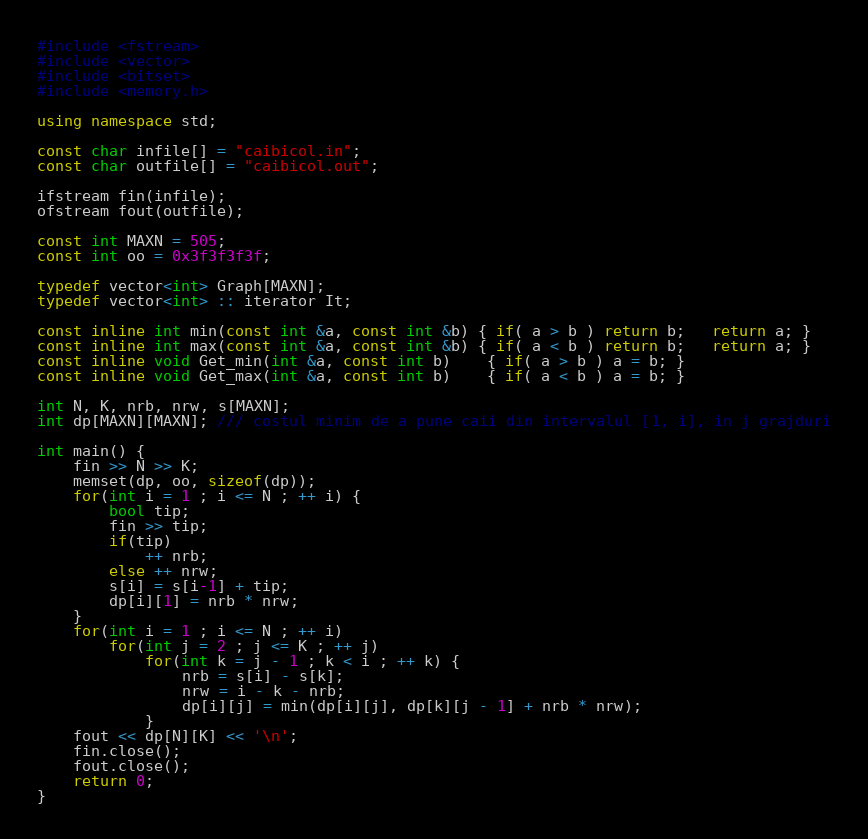Convert code to text. <code><loc_0><loc_0><loc_500><loc_500><_C++_>#include <fstream>
#include <vector>
#include <bitset>
#include <memory.h>

using namespace std;

const char infile[] = "caibicol.in";
const char outfile[] = "caibicol.out";

ifstream fin(infile);
ofstream fout(outfile);

const int MAXN = 505;
const int oo = 0x3f3f3f3f;

typedef vector<int> Graph[MAXN];
typedef vector<int> :: iterator It;

const inline int min(const int &a, const int &b) { if( a > b ) return b;   return a; }
const inline int max(const int &a, const int &b) { if( a < b ) return b;   return a; }
const inline void Get_min(int &a, const int b)    { if( a > b ) a = b; }
const inline void Get_max(int &a, const int b)    { if( a < b ) a = b; }

int N, K, nrb, nrw, s[MAXN];
int dp[MAXN][MAXN]; /// costul minim de a pune caii din intervalul [1, i], in j grajduri

int main() {
    fin >> N >> K;
    memset(dp, oo, sizeof(dp));
    for(int i = 1 ; i <= N ; ++ i) {
        bool tip;
        fin >> tip;
        if(tip)
            ++ nrb;
        else ++ nrw;
        s[i] = s[i-1] + tip;
        dp[i][1] = nrb * nrw;
    }
    for(int i = 1 ; i <= N ; ++ i)
        for(int j = 2 ; j <= K ; ++ j)
            for(int k = j - 1 ; k < i ; ++ k) {
                nrb = s[i] - s[k];
                nrw = i - k - nrb;
                dp[i][j] = min(dp[i][j], dp[k][j - 1] + nrb * nrw);
            }
    fout << dp[N][K] << '\n';
    fin.close();
    fout.close();
    return 0;
}
</code> 